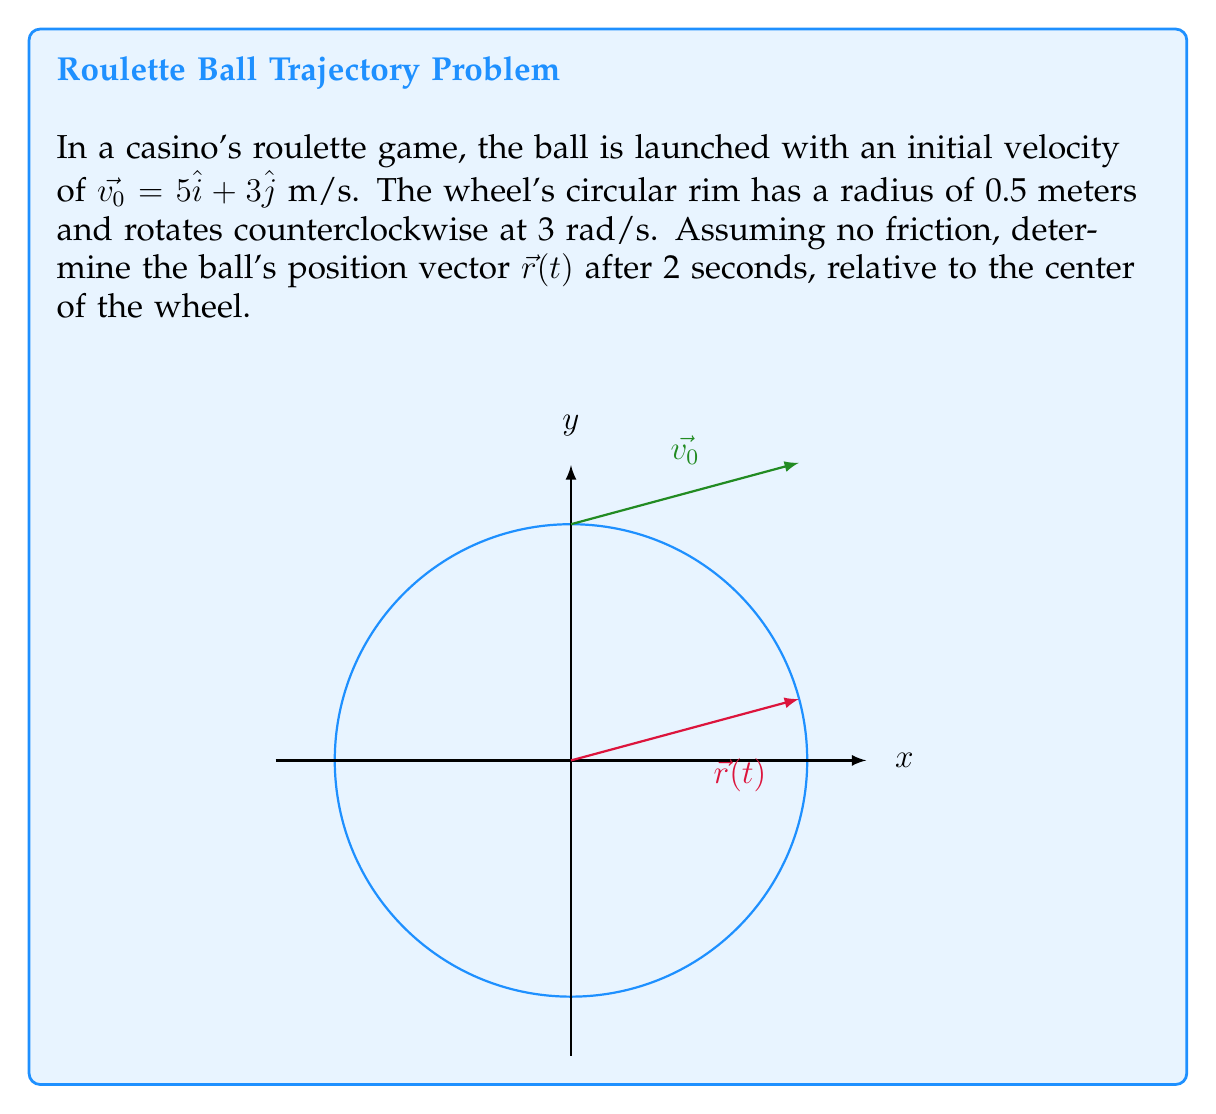Teach me how to tackle this problem. Let's approach this step-by-step:

1) The position vector $\vec{r}(t)$ in polar coordinates is given by:
   $$\vec{r}(t) = R(\cos(\omega t)\hat{i} + \sin(\omega t)\hat{j})$$
   where $R$ is the radius, $\omega$ is the angular velocity, and $t$ is time.

2) We're given:
   $R = 0.5$ m
   $\omega = 3$ rad/s
   $t = 2$ s

3) Substituting these values:
   $$\vec{r}(t) = 0.5(\cos(3 \cdot 2)\hat{i} + \sin(3 \cdot 2)\hat{j})$$
   $$\vec{r}(t) = 0.5(\cos(6)\hat{i} + \sin(6)\hat{j})$$

4) Calculate:
   $\cos(6) \approx 0.9602$
   $\sin(6) \approx -0.2794$

5) Therefore:
   $$\vec{r}(t) = 0.5(0.9602\hat{i} - 0.2794\hat{j})$$
   $$\vec{r}(t) = 0.4801\hat{i} - 0.1397\hat{j}$$

6) The final position vector after 2 seconds is:
   $$\vec{r}(2) = 0.4801\hat{i} - 0.1397\hat{j}$$ (in meters)
Answer: $\vec{r}(2) = 0.4801\hat{i} - 0.1397\hat{j}$ m 